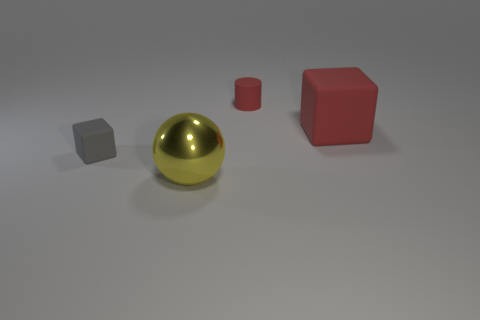There is a red cylinder; does it have the same size as the block in front of the red rubber cube?
Your answer should be very brief. Yes. Are there fewer blocks on the left side of the small cylinder than things?
Make the answer very short. Yes. What number of other large things have the same color as the large metal object?
Your response must be concise. 0. Is the number of large metal spheres less than the number of big green metal balls?
Offer a very short reply. No. Is the material of the tiny cube the same as the small cylinder?
Give a very brief answer. Yes. How many other objects are there of the same size as the red cube?
Offer a terse response. 1. The tiny matte object behind the cube in front of the big red rubber object is what color?
Your response must be concise. Red. What number of other objects are there of the same shape as the tiny red matte thing?
Your answer should be compact. 0. Are there any large blue cubes that have the same material as the big yellow object?
Offer a very short reply. No. There is a sphere that is the same size as the red block; what is it made of?
Offer a very short reply. Metal. 